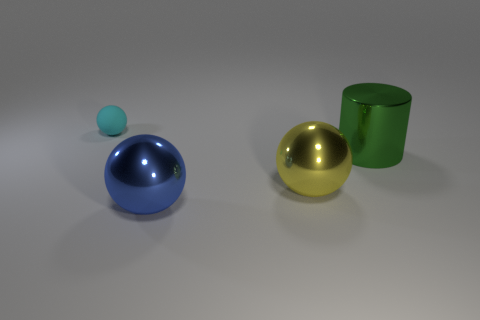Subtract all small cyan balls. How many balls are left? 2 Add 2 large balls. How many objects exist? 6 Subtract all spheres. How many objects are left? 1 Subtract 1 green cylinders. How many objects are left? 3 Subtract all cyan balls. Subtract all green shiny cylinders. How many objects are left? 2 Add 3 large metallic spheres. How many large metallic spheres are left? 5 Add 2 big blue things. How many big blue things exist? 3 